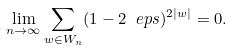Convert formula to latex. <formula><loc_0><loc_0><loc_500><loc_500>\lim _ { n \to \infty } \sum _ { w \in W _ { n } } ( 1 - 2 \ e p s ) ^ { 2 | w | } = 0 .</formula> 